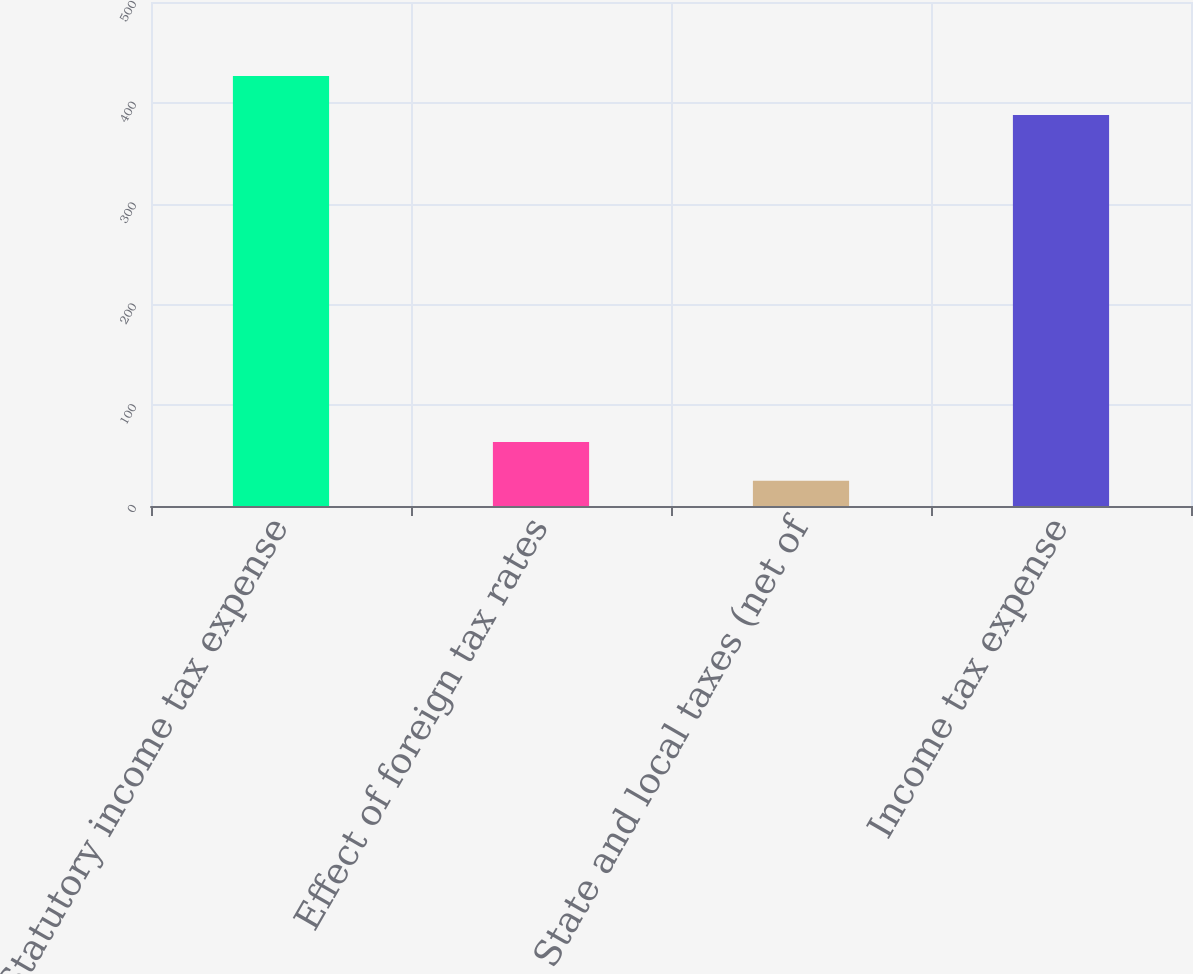Convert chart to OTSL. <chart><loc_0><loc_0><loc_500><loc_500><bar_chart><fcel>Statutory income tax expense<fcel>Effect of foreign tax rates<fcel>State and local taxes (net of<fcel>Income tax expense<nl><fcel>426.6<fcel>63.6<fcel>25<fcel>388<nl></chart> 